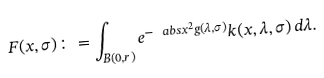<formula> <loc_0><loc_0><loc_500><loc_500>F ( x , \sigma ) \colon = \int _ { B ( 0 , r ) } e ^ { - \ a b s { x } ^ { 2 } g ( \lambda , \sigma ) } k ( x , \lambda , \sigma ) \, d \lambda .</formula> 